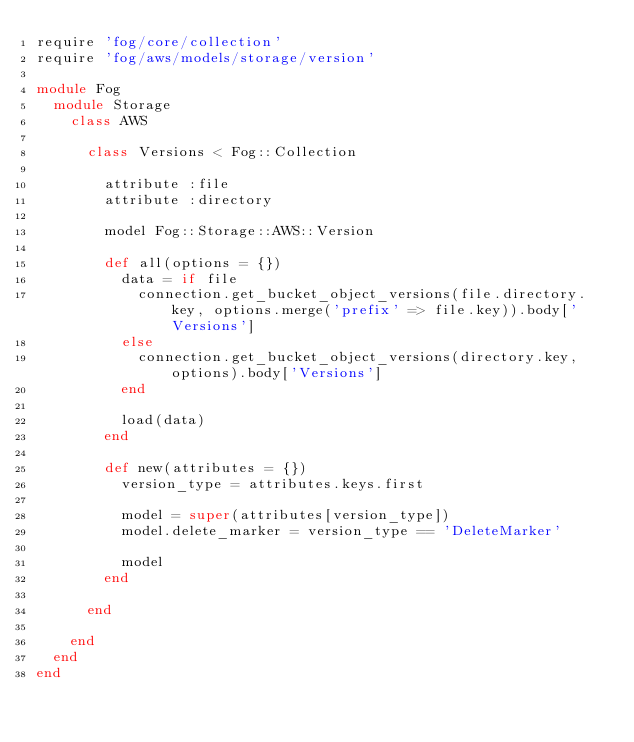<code> <loc_0><loc_0><loc_500><loc_500><_Ruby_>require 'fog/core/collection'
require 'fog/aws/models/storage/version'

module Fog
  module Storage
    class AWS

      class Versions < Fog::Collection

        attribute :file
        attribute :directory

        model Fog::Storage::AWS::Version

        def all(options = {})
          data = if file
            connection.get_bucket_object_versions(file.directory.key, options.merge('prefix' => file.key)).body['Versions']
          else
            connection.get_bucket_object_versions(directory.key, options).body['Versions']
          end

          load(data)
        end

        def new(attributes = {})
          version_type = attributes.keys.first

          model = super(attributes[version_type])
          model.delete_marker = version_type == 'DeleteMarker'

          model
        end

      end

    end
  end
end</code> 